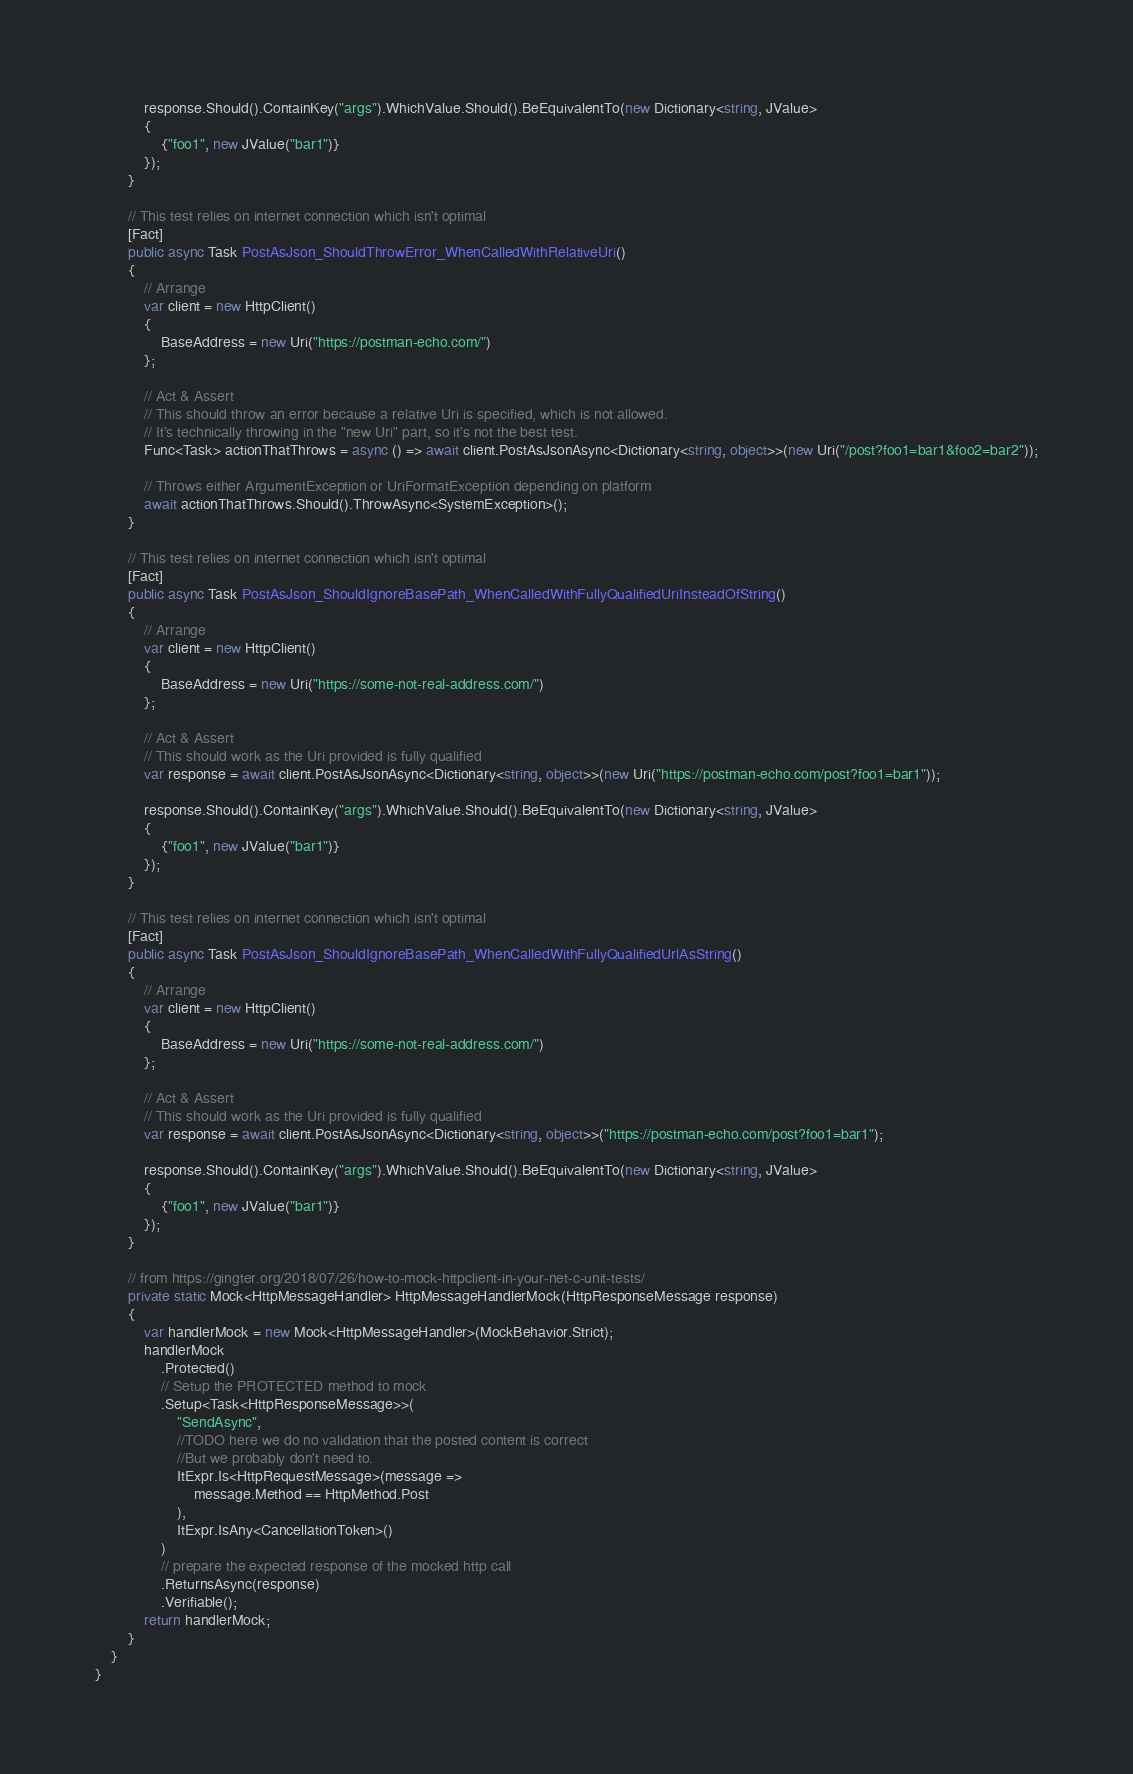Convert code to text. <code><loc_0><loc_0><loc_500><loc_500><_C#_>
            response.Should().ContainKey("args").WhichValue.Should().BeEquivalentTo(new Dictionary<string, JValue>
            {
                {"foo1", new JValue("bar1")}
            });
        }

        // This test relies on internet connection which isn't optimal
        [Fact]
        public async Task PostAsJson_ShouldThrowError_WhenCalledWithRelativeUri()
        {
            // Arrange
            var client = new HttpClient()
            {
                BaseAddress = new Uri("https://postman-echo.com/")
            };

            // Act & Assert
            // This should throw an error because a relative Uri is specified, which is not allowed.
            // It's technically throwing in the "new Uri" part, so it's not the best test.
            Func<Task> actionThatThrows = async () => await client.PostAsJsonAsync<Dictionary<string, object>>(new Uri("/post?foo1=bar1&foo2=bar2"));

            // Throws either ArgumentException or UriFormatException depending on platform
            await actionThatThrows.Should().ThrowAsync<SystemException>();
        }

        // This test relies on internet connection which isn't optimal
        [Fact]
        public async Task PostAsJson_ShouldIgnoreBasePath_WhenCalledWithFullyQualifiedUriInsteadOfString()
        {
            // Arrange
            var client = new HttpClient()
            {
                BaseAddress = new Uri("https://some-not-real-address.com/")
            };

            // Act & Assert
            // This should work as the Uri provided is fully qualified
            var response = await client.PostAsJsonAsync<Dictionary<string, object>>(new Uri("https://postman-echo.com/post?foo1=bar1"));

            response.Should().ContainKey("args").WhichValue.Should().BeEquivalentTo(new Dictionary<string, JValue>
            {
                {"foo1", new JValue("bar1")}
            });
        }

        // This test relies on internet connection which isn't optimal
        [Fact]
        public async Task PostAsJson_ShouldIgnoreBasePath_WhenCalledWithFullyQualifiedUrlAsString()
        {
            // Arrange
            var client = new HttpClient()
            {
                BaseAddress = new Uri("https://some-not-real-address.com/")
            };

            // Act & Assert
            // This should work as the Uri provided is fully qualified
            var response = await client.PostAsJsonAsync<Dictionary<string, object>>("https://postman-echo.com/post?foo1=bar1");

            response.Should().ContainKey("args").WhichValue.Should().BeEquivalentTo(new Dictionary<string, JValue>
            {
                {"foo1", new JValue("bar1")}
            });
        }

        // from https://gingter.org/2018/07/26/how-to-mock-httpclient-in-your-net-c-unit-tests/
        private static Mock<HttpMessageHandler> HttpMessageHandlerMock(HttpResponseMessage response)
        {
            var handlerMock = new Mock<HttpMessageHandler>(MockBehavior.Strict);
            handlerMock
                .Protected()
                // Setup the PROTECTED method to mock
                .Setup<Task<HttpResponseMessage>>(
                    "SendAsync",
                    //TODO here we do no validation that the posted content is correct
                    //But we probably don't need to.
                    ItExpr.Is<HttpRequestMessage>(message =>
                        message.Method == HttpMethod.Post
                    ),
                    ItExpr.IsAny<CancellationToken>()
                )
                // prepare the expected response of the mocked http call
                .ReturnsAsync(response)
                .Verifiable();
            return handlerMock;
        }
    }
}
</code> 